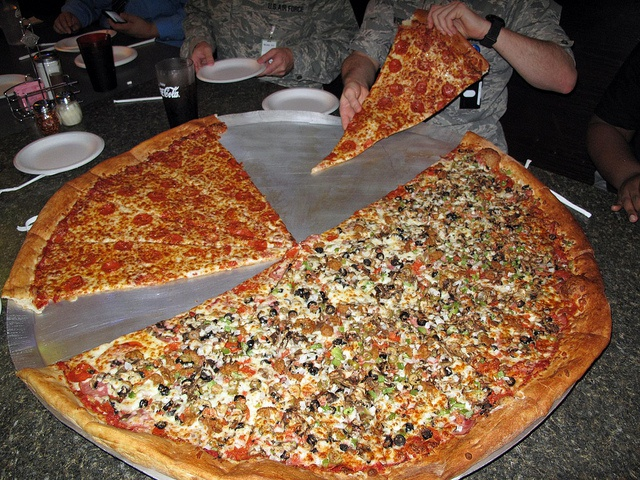Describe the objects in this image and their specific colors. I can see dining table in black, brown, gray, and maroon tones, pizza in black, brown, tan, and maroon tones, people in black, gray, and maroon tones, people in black, gray, and maroon tones, and people in black, maroon, and brown tones in this image. 